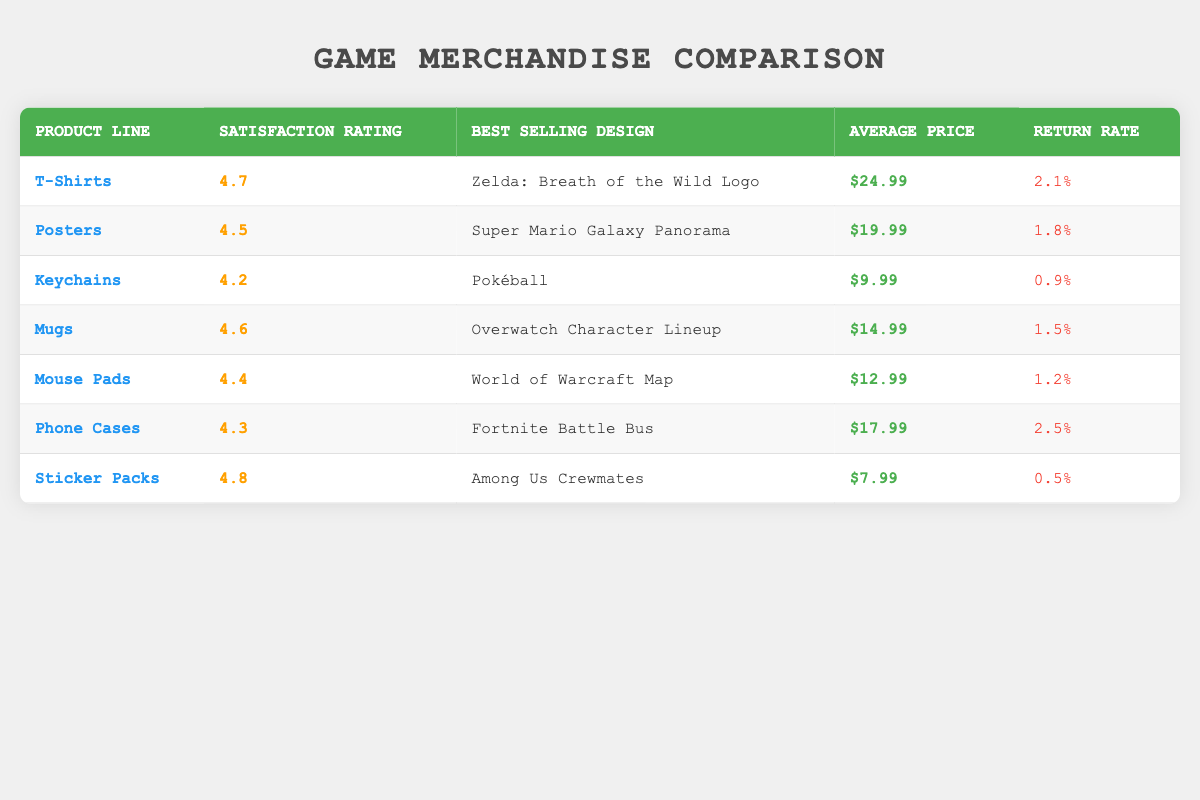What is the satisfaction rating for T-Shirts? The satisfaction rating for T-Shirts is listed in the table, specifically under the column for satisfaction rating, which shows a value of 4.7.
Answer: 4.7 Which product line has the highest return rate? To find the highest return rate, I review the return rate column for all product lines. The rates listed are 2.1%, 1.8%, 0.9%, 1.5%, 1.2%, 2.5%, and 0.5%. The highest value is 2.5%, which corresponds to Phone Cases.
Answer: Phone Cases What is the average price of the Mouse Pads? The average price of Mouse Pads is directly shown in the table under the price column, which specifies that it is $12.99.
Answer: $12.99 How many product lines have a satisfaction rating below 4.4? I will check the satisfaction ratings for each product line. The ratings are 4.7, 4.5, 4.2, 4.6, 4.4, 4.3, and 4.8. The only product line with a rating below 4.4 is the Keychains with a rating of 4.2. Thus, there is one product line below this threshold.
Answer: 1 Is the best-selling design for Keychains a Pokéball? According to the table, the best-selling design for the Keychains is explicitly stated as "Pokéball". Thus, the statement is true.
Answer: Yes What is the difference in satisfaction ratings between Sticker Packs and Mugs? The satisfaction rating for Sticker Packs is 4.8 and for Mugs, it is 4.6. To find the difference, I subtract the rating of Mugs from Sticker Packs: 4.8 - 4.6 = 0.2.
Answer: 0.2 Which product has a satisfaction rating closest to the average of all product lines? I need to calculate the average satisfaction rating of all listed product lines. The ratings are 4.7, 4.5, 4.2, 4.6, 4.4, 4.3, and 4.8. Their total is 28.5, and there are 7 product lines, so the average is 28.5 / 7 = 4.0714 (approximately 4.07). The satisfaction ratings closest to this average are Phone Cases (4.3) and Keychains (4.2).
Answer: Phone Cases and Keychains How do the satisfaction ratings for Posters and Mugs compare? I will look at the satisfaction ratings for both Posters and Mugs. The Posters have a rating of 4.5, and Mugs have a rating of 4.6. Since 4.6 is greater than 4.5, Mugs have a higher satisfaction rating.
Answer: Mugs have a higher rating Is the average return rate for T-Shirts higher than that of Sticker Packs? The return rates for T-Shirts and Sticker Packs are 2.1% and 0.5%, respectively. Since 2.1% is greater than 0.5%, the average return rate for T-Shirts is indeed higher.
Answer: Yes 